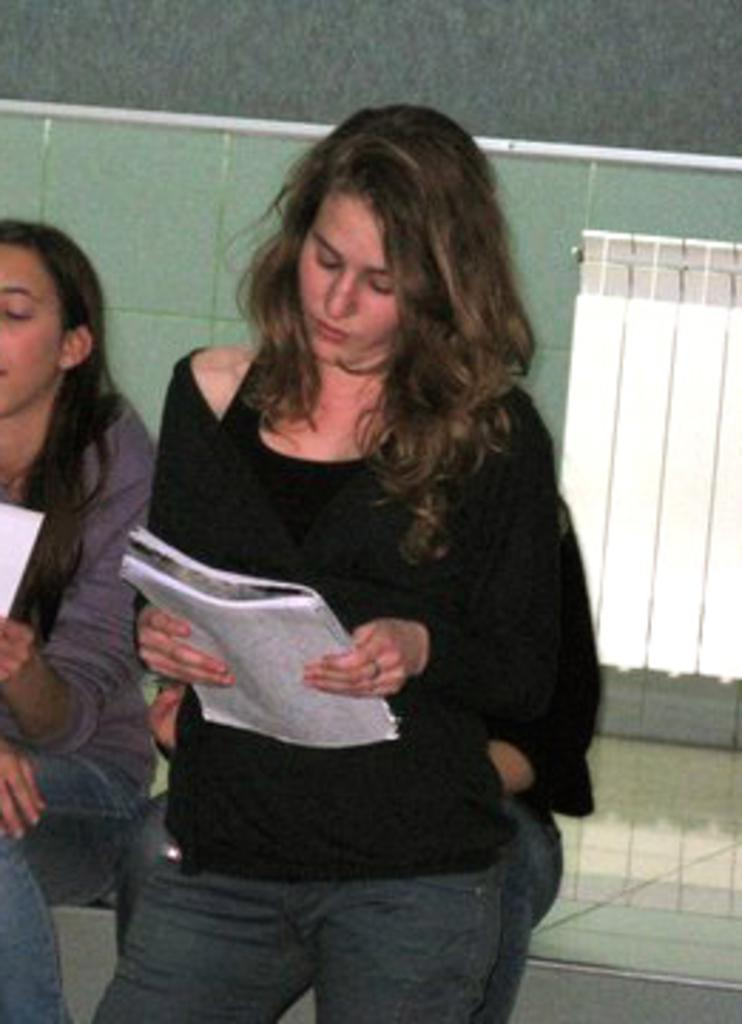What is the lady in the foreground of the image holding? The lady is holding a book in the image. Can you describe the people in the background of the image? There are two persons in the background of the image. What is the lady on the left side of the image holding? The lady on the left is holding something in her hand. What can be seen on the wall in the background of the image? There is a wall with a window in the background of the image. What type of recess can be seen in the image? There is no recess present in the image. How many trains are visible in the image? There are no trains visible in the image. 